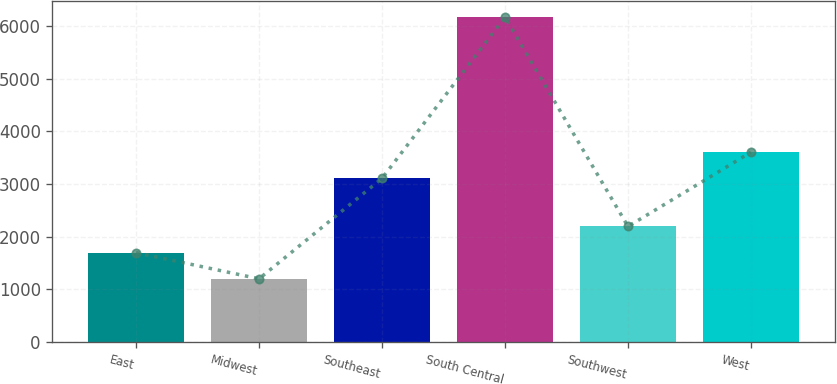Convert chart to OTSL. <chart><loc_0><loc_0><loc_500><loc_500><bar_chart><fcel>East<fcel>Midwest<fcel>Southeast<fcel>South Central<fcel>Southwest<fcel>West<nl><fcel>1695.4<fcel>1198<fcel>3107<fcel>6172<fcel>2192.8<fcel>3604.4<nl></chart> 